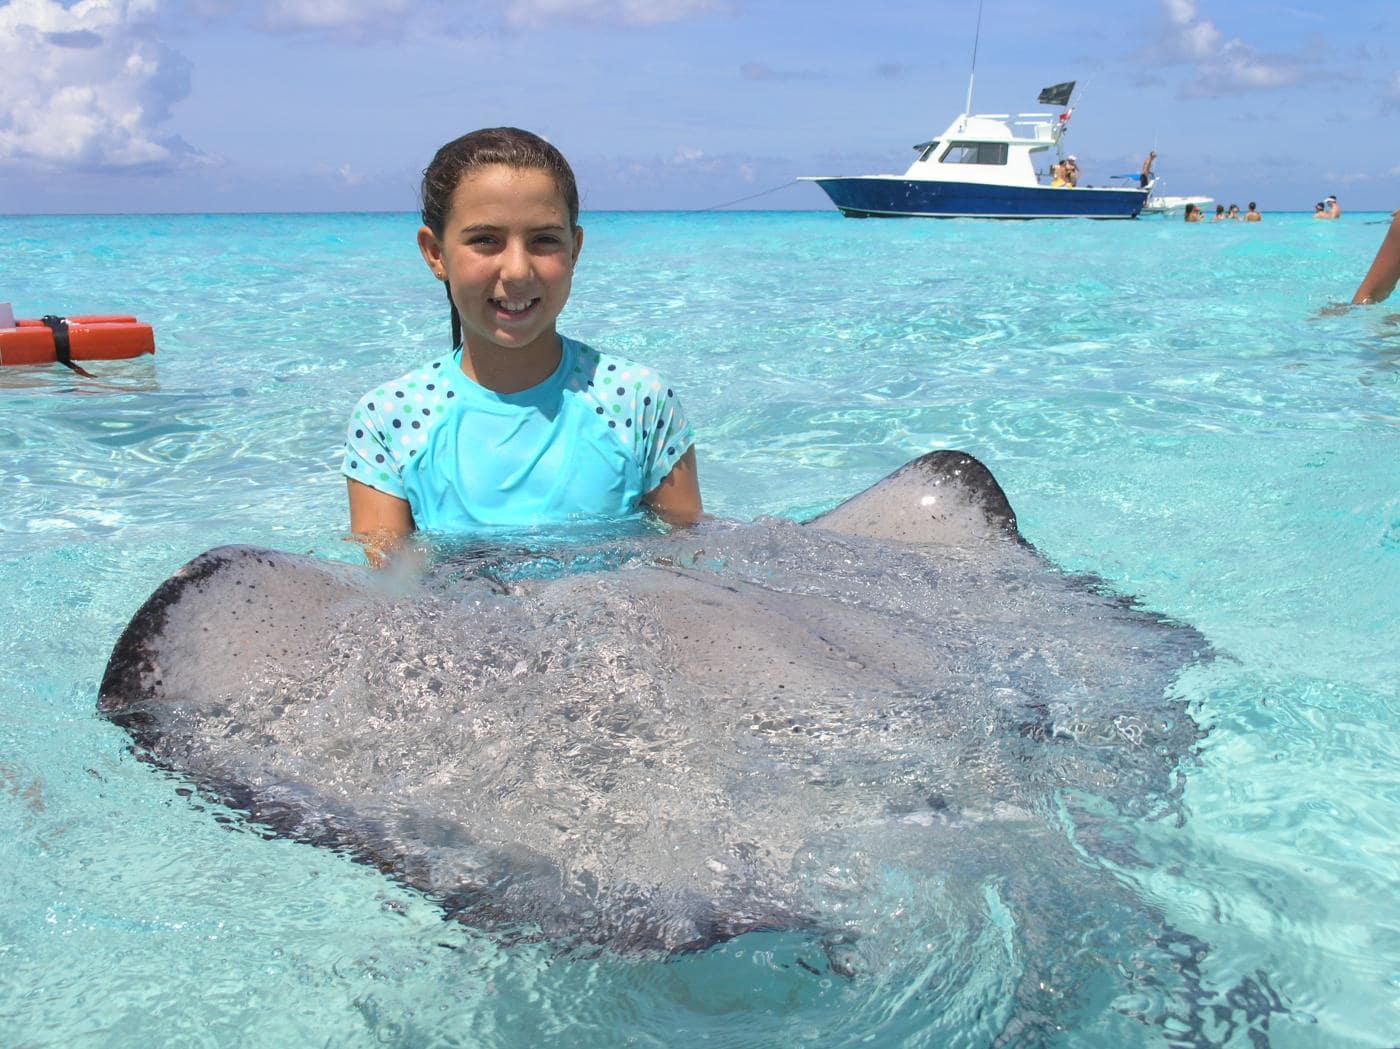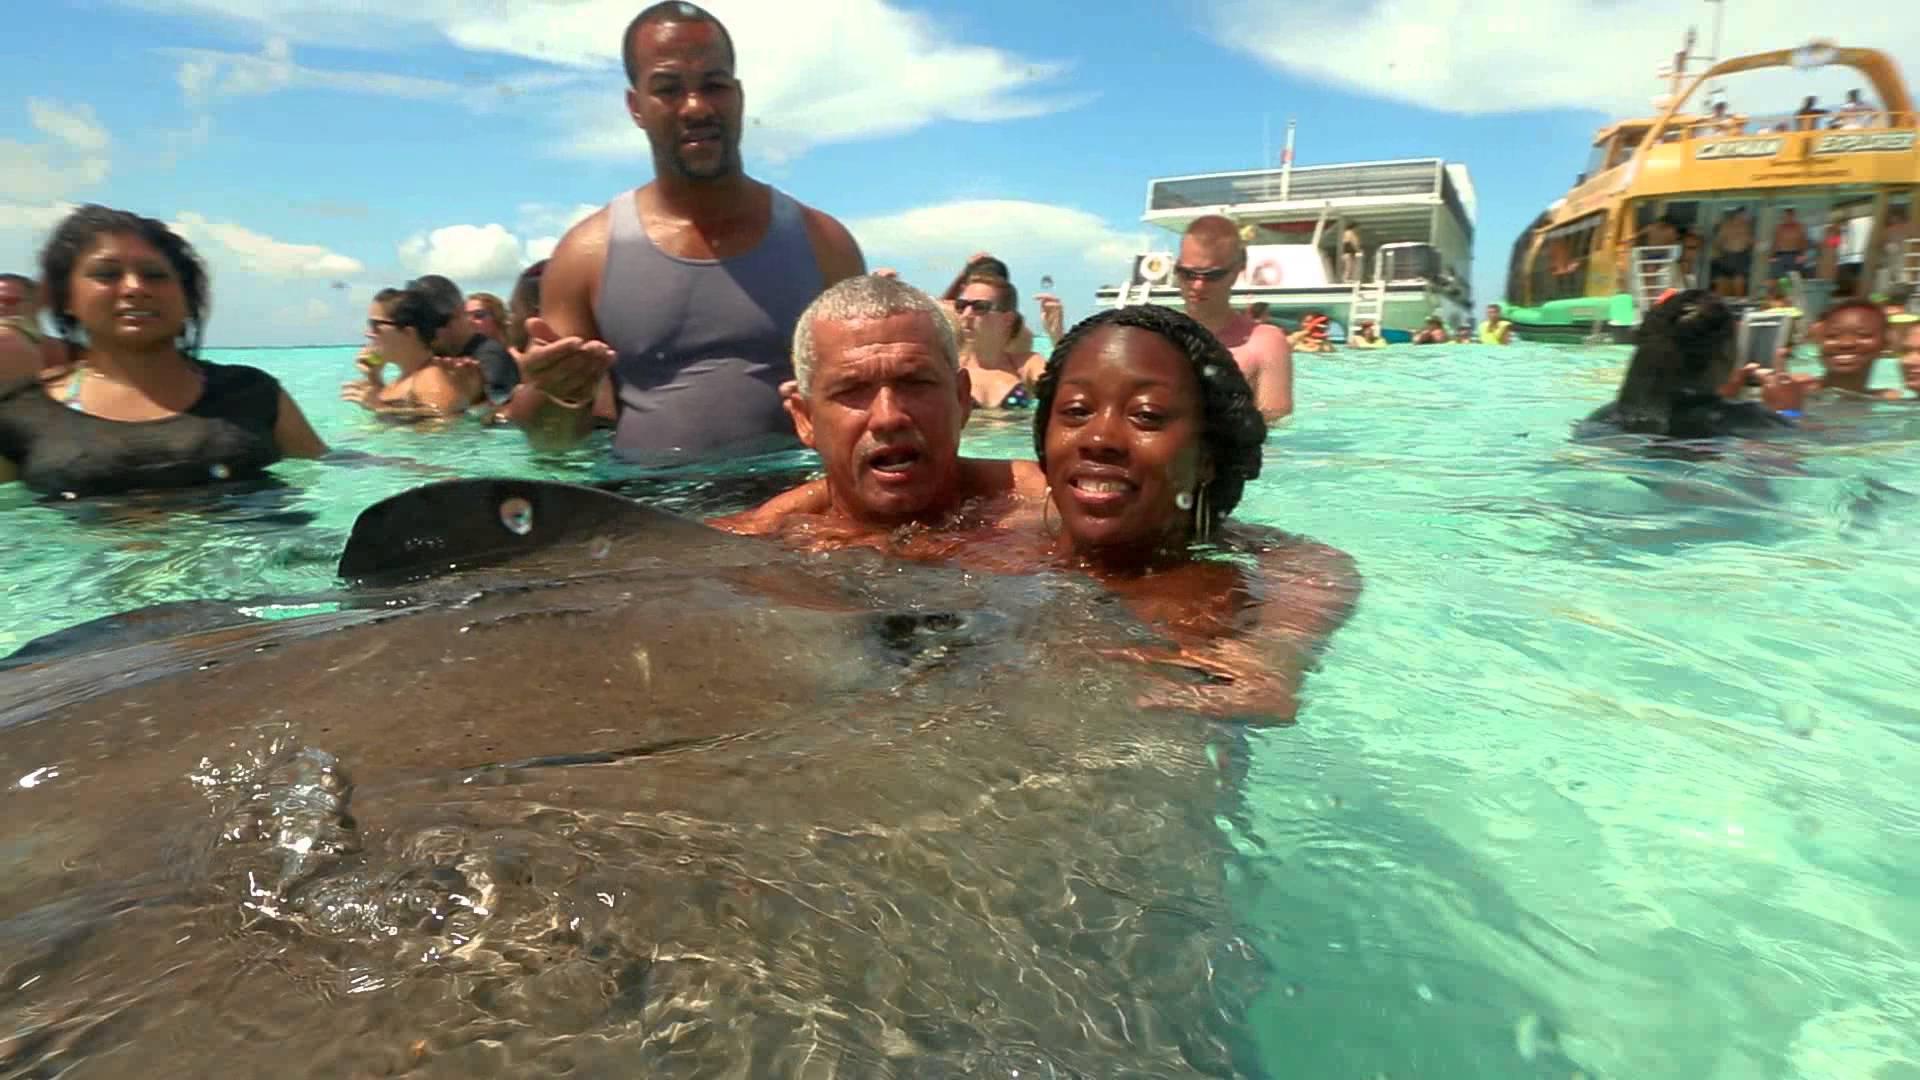The first image is the image on the left, the second image is the image on the right. For the images shown, is this caption "Left image shows one brown-haired girl interacting with a large light gray stingray." true? Answer yes or no. Yes. The first image is the image on the left, the second image is the image on the right. Evaluate the accuracy of this statement regarding the images: "A female in the image on the left is standing in the water with a ray.". Is it true? Answer yes or no. Yes. 